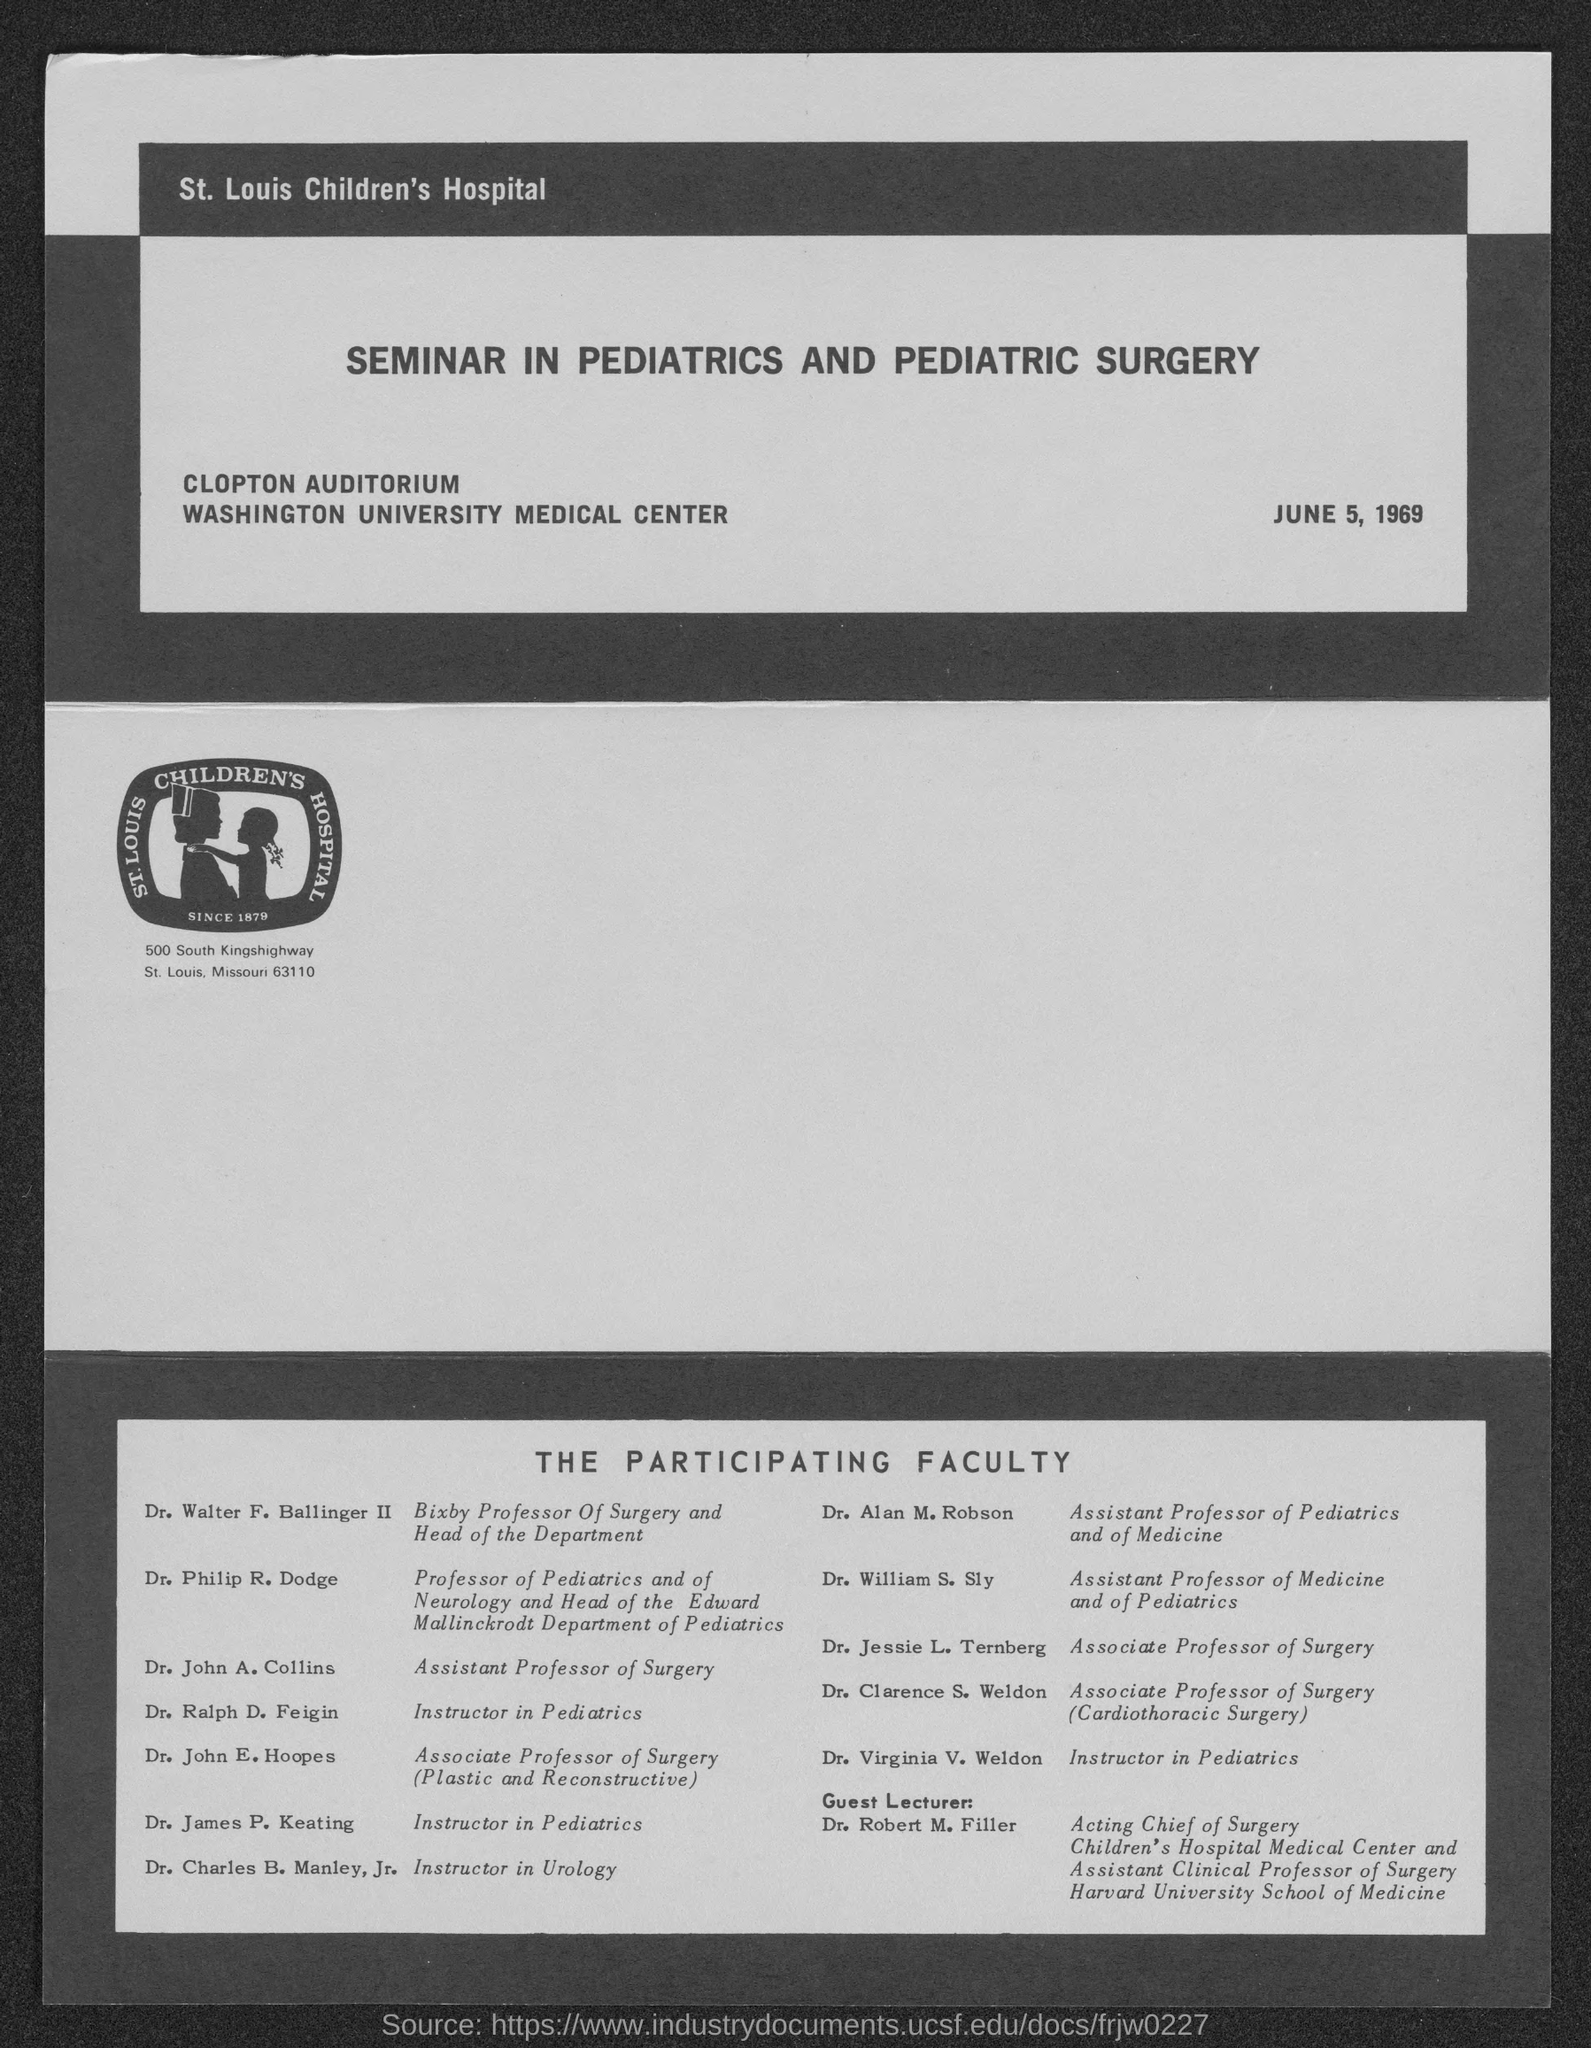Who is the guest lecturer?
Make the answer very short. DR. ROBERT M. FILLER. What is the address of st. louis children's hospital?
Offer a very short reply. 500 South Kingshighway St. Louis, Missouri 63110. 